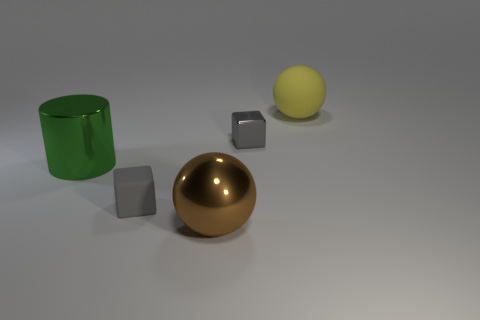What number of things are cylinders that are to the left of the large shiny sphere or matte things?
Provide a succinct answer. 3. What is the material of the large green cylinder?
Your response must be concise. Metal. Do the gray shiny block and the shiny ball have the same size?
Your answer should be compact. No. How many cylinders are either yellow rubber things or big metal objects?
Your answer should be very brief. 1. The tiny thing that is on the left side of the sphere left of the big rubber ball is what color?
Provide a short and direct response. Gray. Is the number of shiny cubes right of the tiny gray shiny object less than the number of rubber things that are behind the yellow object?
Ensure brevity in your answer.  No. There is a yellow matte ball; is it the same size as the rubber object in front of the big matte thing?
Provide a short and direct response. No. What shape is the big object that is right of the green shiny object and in front of the gray metal object?
Your answer should be very brief. Sphere. There is a block that is made of the same material as the large brown object; what size is it?
Provide a short and direct response. Small. How many brown metal spheres are on the right side of the cube behind the big green cylinder?
Your answer should be very brief. 0. 